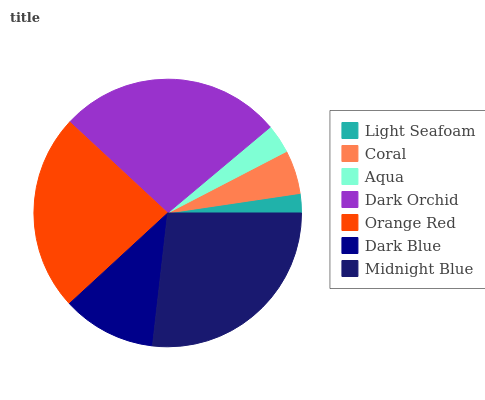Is Light Seafoam the minimum?
Answer yes or no. Yes. Is Dark Orchid the maximum?
Answer yes or no. Yes. Is Coral the minimum?
Answer yes or no. No. Is Coral the maximum?
Answer yes or no. No. Is Coral greater than Light Seafoam?
Answer yes or no. Yes. Is Light Seafoam less than Coral?
Answer yes or no. Yes. Is Light Seafoam greater than Coral?
Answer yes or no. No. Is Coral less than Light Seafoam?
Answer yes or no. No. Is Dark Blue the high median?
Answer yes or no. Yes. Is Dark Blue the low median?
Answer yes or no. Yes. Is Orange Red the high median?
Answer yes or no. No. Is Aqua the low median?
Answer yes or no. No. 